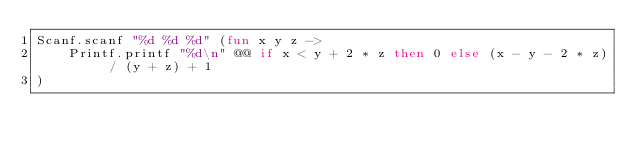Convert code to text. <code><loc_0><loc_0><loc_500><loc_500><_OCaml_>Scanf.scanf "%d %d %d" (fun x y z ->
    Printf.printf "%d\n" @@ if x < y + 2 * z then 0 else (x - y - 2 * z) / (y + z) + 1
)</code> 